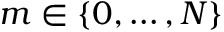<formula> <loc_0><loc_0><loc_500><loc_500>m \in \{ 0 , \dots , N \}</formula> 